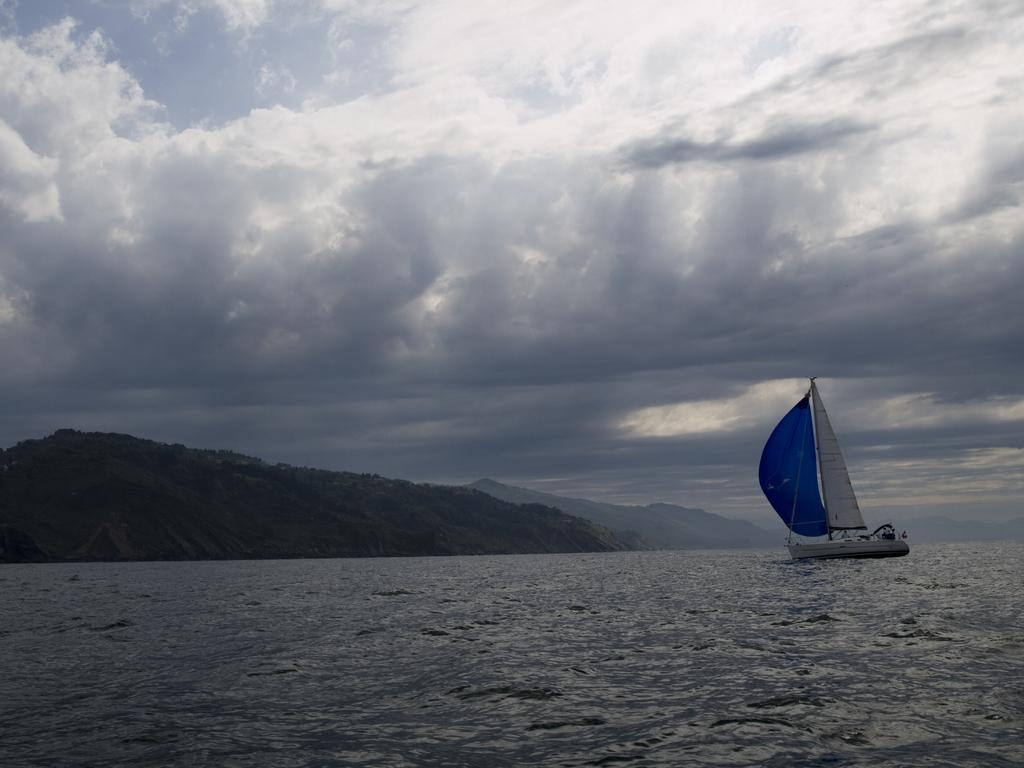What is the main feature of the image? There is water in the image. What is located on the water? There is a boat on the water, on the right side. What type of natural landscape can be seen in the image? Mountains are visible in the image. How would you describe the weather in the image? The sky is cloudy at the top of the image. How does the process of digestion affect the children in the image? There are no children present in the image, and therefore the process of digestion cannot be observed or discussed. 